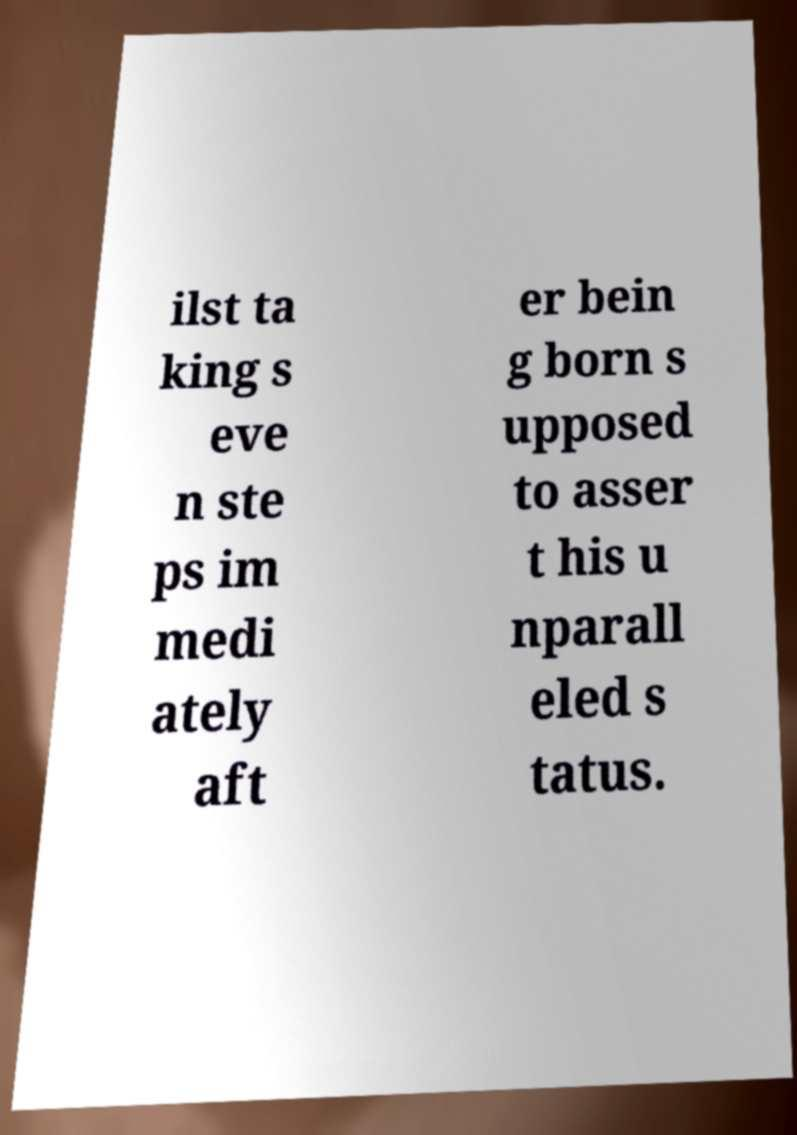Please read and relay the text visible in this image. What does it say? ilst ta king s eve n ste ps im medi ately aft er bein g born s upposed to asser t his u nparall eled s tatus. 